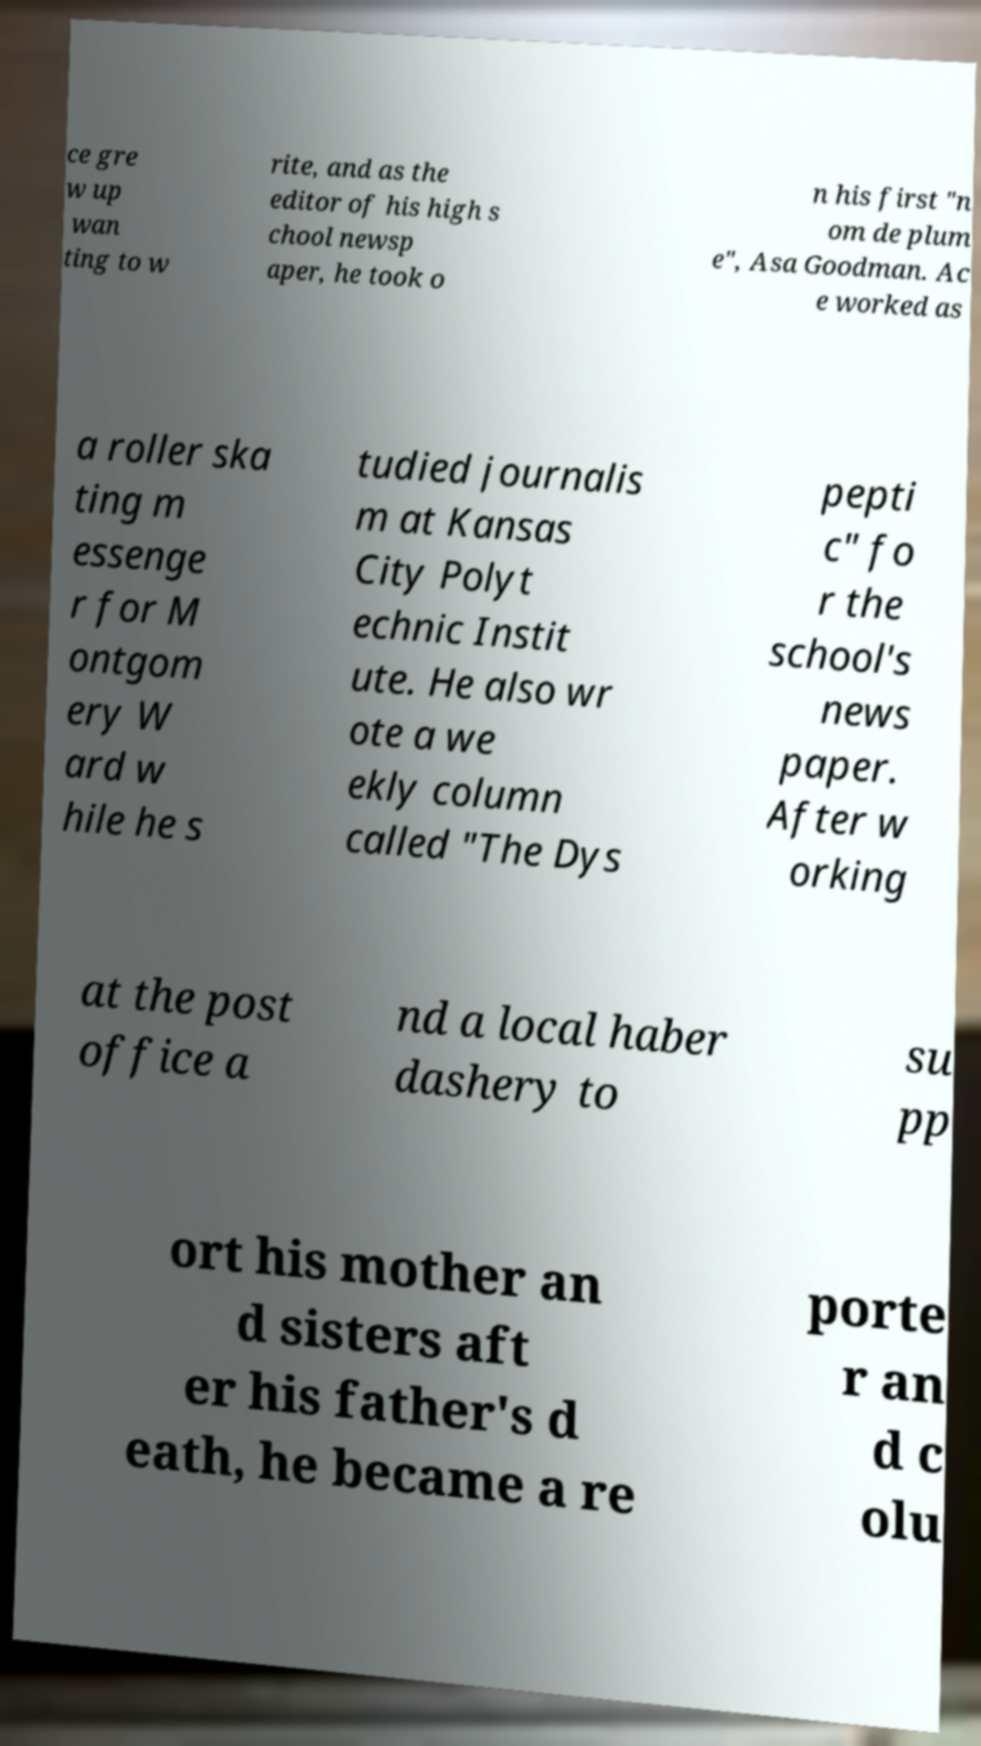I need the written content from this picture converted into text. Can you do that? ce gre w up wan ting to w rite, and as the editor of his high s chool newsp aper, he took o n his first "n om de plum e", Asa Goodman. Ac e worked as a roller ska ting m essenge r for M ontgom ery W ard w hile he s tudied journalis m at Kansas City Polyt echnic Instit ute. He also wr ote a we ekly column called "The Dys pepti c" fo r the school's news paper. After w orking at the post office a nd a local haber dashery to su pp ort his mother an d sisters aft er his father's d eath, he became a re porte r an d c olu 